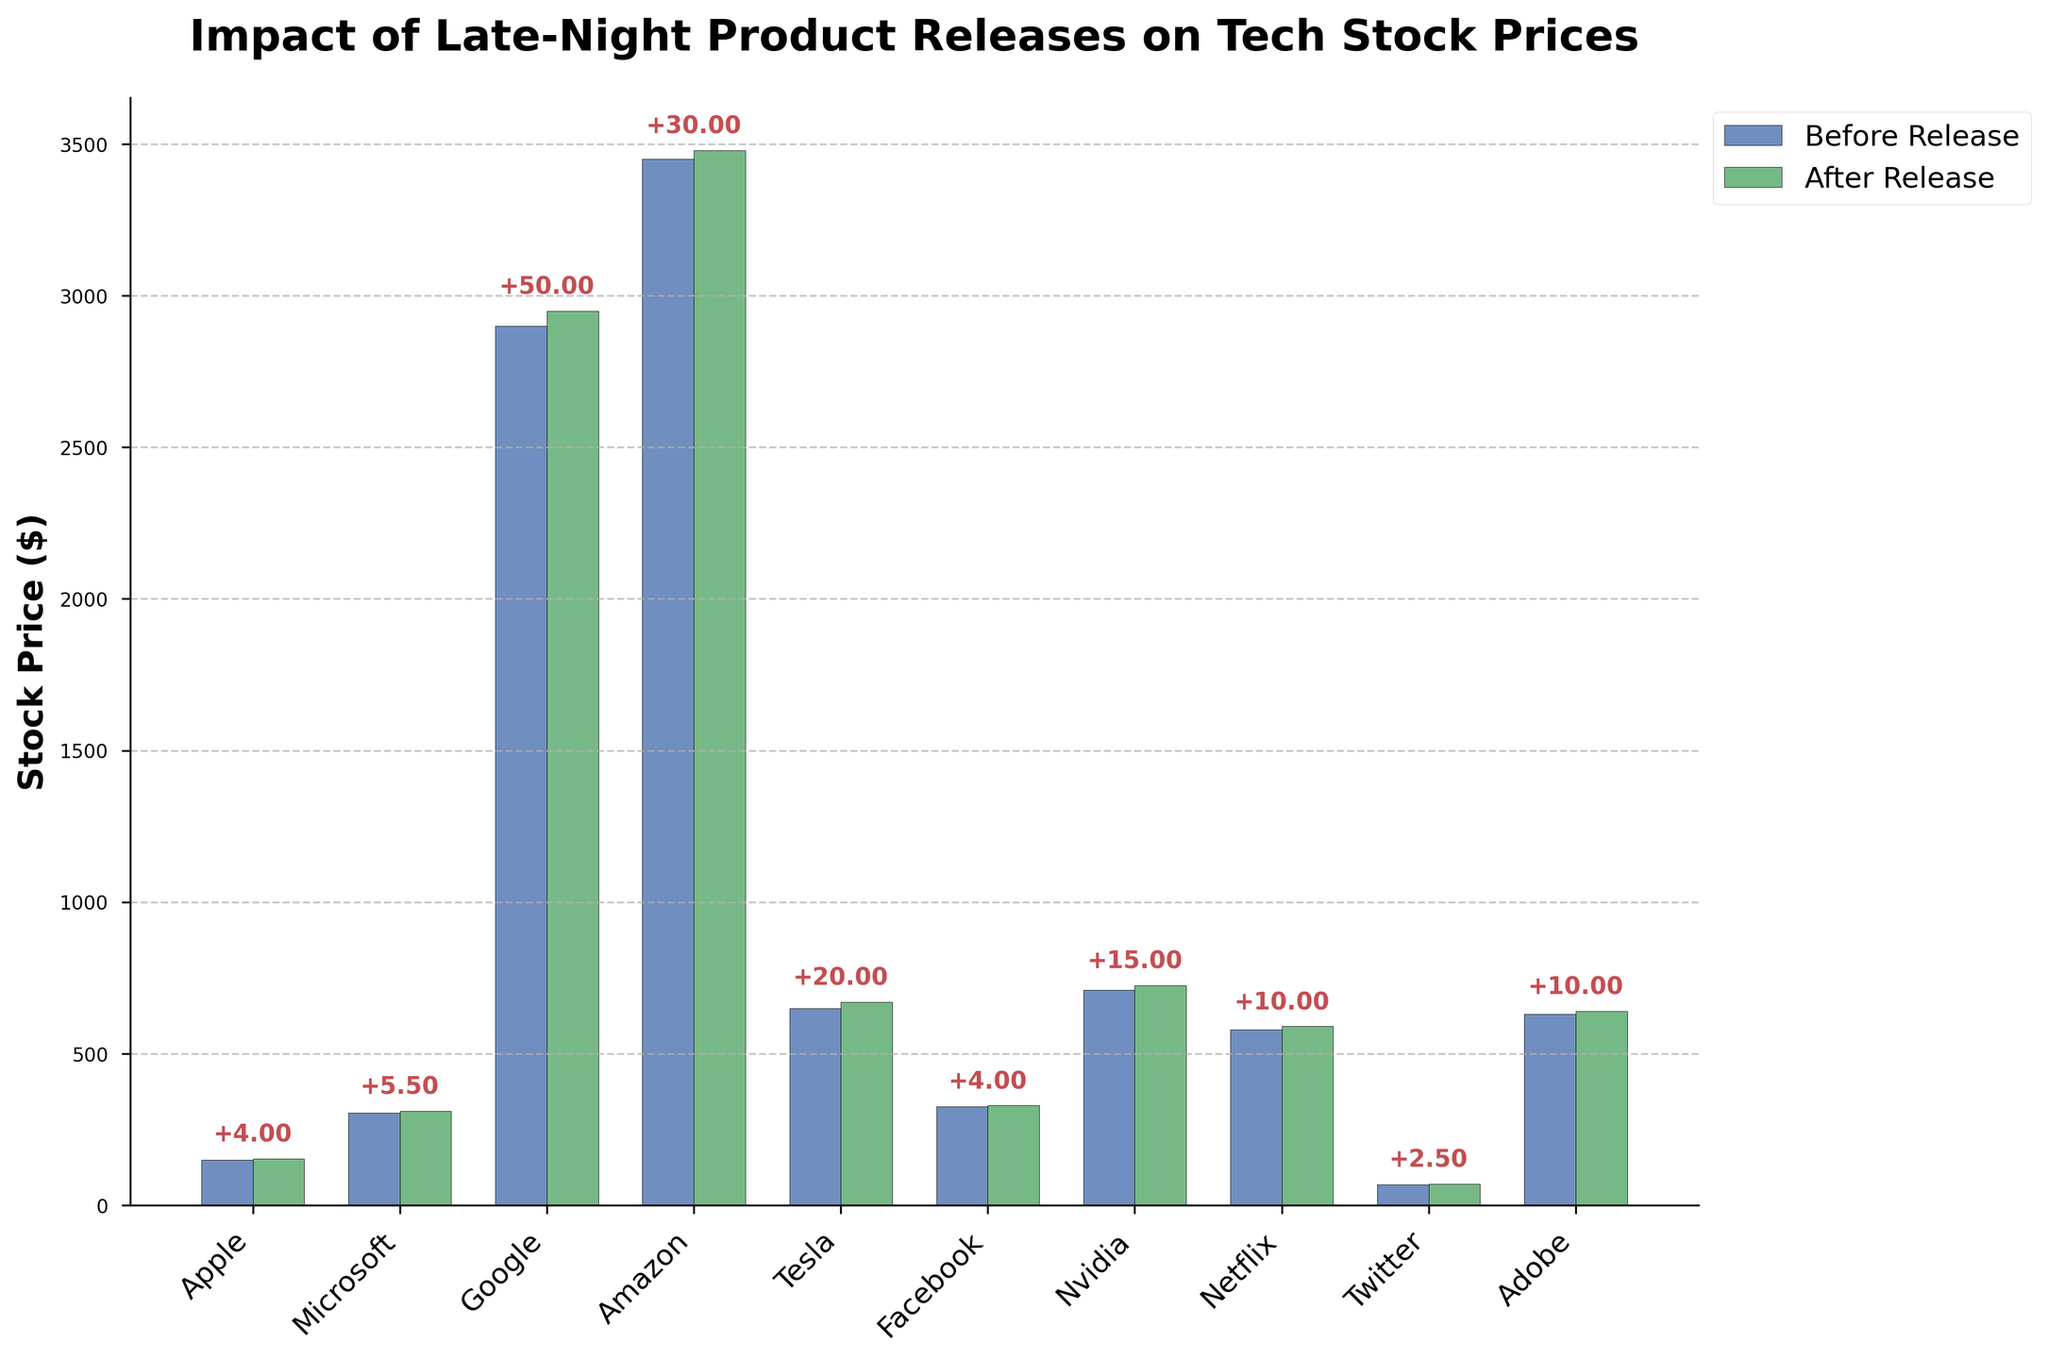What is the title of the figure? The title is at the top of the figure, typically bold and larger in font size. It reads "Impact of Late-Night Product Releases on Tech Stock Prices."
Answer: Impact of Late-Night Product Releases on Tech Stock Prices What are the colors used in the bars to represent stock prices before and after product releases? The bar representing stock prices before releases is colored blue, while the bar for stock prices after releases is green.
Answer: Blue and Green How many companies are represented in the figure? Count the number of unique company names along the x-axis. There are 10 companies listed: Apple, Microsoft, Google, Amazon, Tesla, Facebook, Nvidia, Netflix, Twitter, and Adobe.
Answer: 10 What company had the highest increase in stock price after their late-night product release? Compare the difference in stock prices before and after the release for each company. Tesla had the highest increase with a $20.00 difference (670.00 - 650.00).
Answer: Tesla Which company had the lowest stock price before the product release? Look along the y-axis and the blue bars. Twitter had the lowest stock price before the release at $68.00.
Answer: Twitter What is the average stock price after the product release for all companies? Add all the stock prices after the release and divide by the number of companies: 
(154.00 + 310.50 + 2950.00 + 3480.00 + 670.00 + 329.00 + 725.00 + 590.00 + 70.50 + 640.00) / 10 = 10890.00 / 10
Answer: 1089.00 Did any company experience a stock price decrease after their late-night product release? Check if any company has a stock price after release lower than before the release. In this dataset, no company experienced a stock price decrease; all changes are positive.
Answer: No What was the stock price change for Apple after their late-night product release? Subtract Apple’s stock price before release from its stock price after release: 154.00 - 150.00 = 4.00
Answer: 4.00 Which company had the smallest increase in stock price after their release, and what was the increase? Find the smallest difference between before and after stock prices. Twitter had the smallest increase, with a $2.50 difference (70.50 - 68.00).
Answer: Twitter, 2.50 Which companies had a stock price greater than $300 before their late-night product release? Identify bars before release over the $300 mark. These companies are Microsoft, Google, Amazon, Facebook, Nvidia, and Adobe.
Answer: Microsoft, Google, Amazon, Facebook, Nvidia, Adobe 